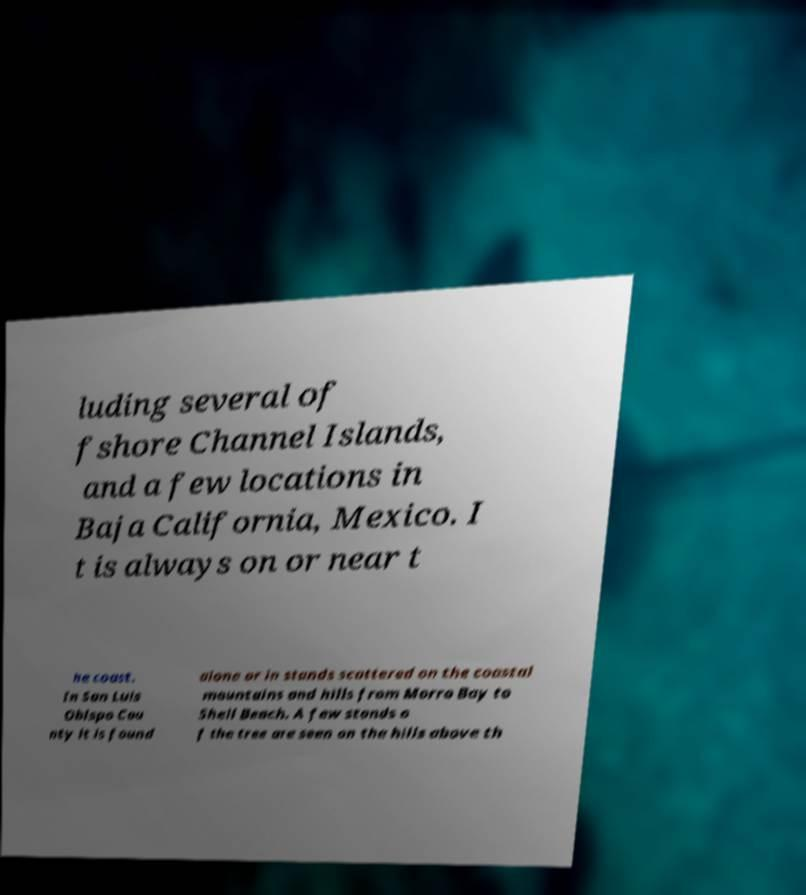Please identify and transcribe the text found in this image. luding several of fshore Channel Islands, and a few locations in Baja California, Mexico. I t is always on or near t he coast. In San Luis Obispo Cou nty it is found alone or in stands scattered on the coastal mountains and hills from Morro Bay to Shell Beach. A few stands o f the tree are seen on the hills above th 